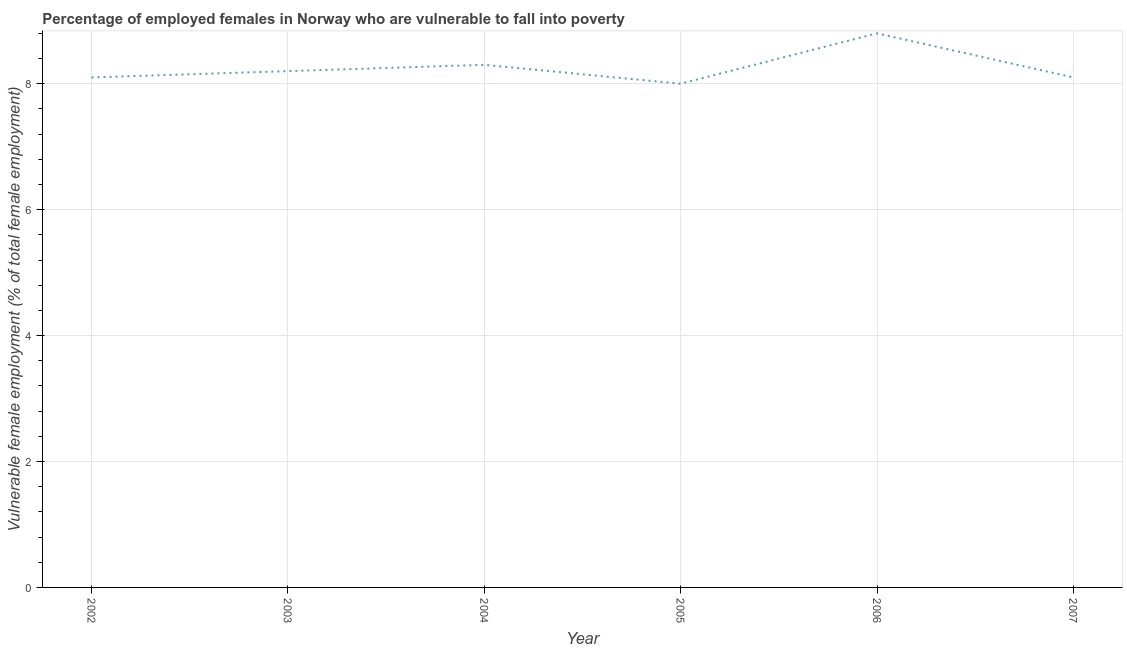What is the percentage of employed females who are vulnerable to fall into poverty in 2004?
Your answer should be very brief. 8.3. Across all years, what is the maximum percentage of employed females who are vulnerable to fall into poverty?
Your answer should be very brief. 8.8. Across all years, what is the minimum percentage of employed females who are vulnerable to fall into poverty?
Provide a short and direct response. 8. In which year was the percentage of employed females who are vulnerable to fall into poverty minimum?
Make the answer very short. 2005. What is the sum of the percentage of employed females who are vulnerable to fall into poverty?
Offer a very short reply. 49.5. What is the difference between the percentage of employed females who are vulnerable to fall into poverty in 2006 and 2007?
Offer a terse response. 0.7. What is the average percentage of employed females who are vulnerable to fall into poverty per year?
Provide a short and direct response. 8.25. What is the median percentage of employed females who are vulnerable to fall into poverty?
Make the answer very short. 8.15. What is the ratio of the percentage of employed females who are vulnerable to fall into poverty in 2002 to that in 2003?
Provide a succinct answer. 0.99. Is the percentage of employed females who are vulnerable to fall into poverty in 2002 less than that in 2005?
Give a very brief answer. No. What is the difference between the highest and the second highest percentage of employed females who are vulnerable to fall into poverty?
Your answer should be compact. 0.5. Is the sum of the percentage of employed females who are vulnerable to fall into poverty in 2004 and 2007 greater than the maximum percentage of employed females who are vulnerable to fall into poverty across all years?
Your answer should be very brief. Yes. What is the difference between the highest and the lowest percentage of employed females who are vulnerable to fall into poverty?
Keep it short and to the point. 0.8. In how many years, is the percentage of employed females who are vulnerable to fall into poverty greater than the average percentage of employed females who are vulnerable to fall into poverty taken over all years?
Your answer should be compact. 2. Does the percentage of employed females who are vulnerable to fall into poverty monotonically increase over the years?
Keep it short and to the point. No. How many lines are there?
Your answer should be compact. 1. How many years are there in the graph?
Give a very brief answer. 6. Does the graph contain any zero values?
Offer a very short reply. No. Does the graph contain grids?
Your answer should be very brief. Yes. What is the title of the graph?
Ensure brevity in your answer.  Percentage of employed females in Norway who are vulnerable to fall into poverty. What is the label or title of the X-axis?
Provide a short and direct response. Year. What is the label or title of the Y-axis?
Give a very brief answer. Vulnerable female employment (% of total female employment). What is the Vulnerable female employment (% of total female employment) of 2002?
Provide a succinct answer. 8.1. What is the Vulnerable female employment (% of total female employment) in 2003?
Your answer should be compact. 8.2. What is the Vulnerable female employment (% of total female employment) in 2004?
Ensure brevity in your answer.  8.3. What is the Vulnerable female employment (% of total female employment) in 2005?
Your response must be concise. 8. What is the Vulnerable female employment (% of total female employment) in 2006?
Provide a succinct answer. 8.8. What is the Vulnerable female employment (% of total female employment) of 2007?
Your response must be concise. 8.1. What is the difference between the Vulnerable female employment (% of total female employment) in 2002 and 2004?
Offer a terse response. -0.2. What is the difference between the Vulnerable female employment (% of total female employment) in 2002 and 2005?
Ensure brevity in your answer.  0.1. What is the difference between the Vulnerable female employment (% of total female employment) in 2002 and 2006?
Ensure brevity in your answer.  -0.7. What is the difference between the Vulnerable female employment (% of total female employment) in 2003 and 2007?
Provide a short and direct response. 0.1. What is the difference between the Vulnerable female employment (% of total female employment) in 2004 and 2005?
Your answer should be compact. 0.3. What is the difference between the Vulnerable female employment (% of total female employment) in 2005 and 2006?
Your response must be concise. -0.8. What is the difference between the Vulnerable female employment (% of total female employment) in 2005 and 2007?
Give a very brief answer. -0.1. What is the difference between the Vulnerable female employment (% of total female employment) in 2006 and 2007?
Offer a terse response. 0.7. What is the ratio of the Vulnerable female employment (% of total female employment) in 2002 to that in 2004?
Ensure brevity in your answer.  0.98. What is the ratio of the Vulnerable female employment (% of total female employment) in 2002 to that in 2005?
Your answer should be compact. 1.01. What is the ratio of the Vulnerable female employment (% of total female employment) in 2002 to that in 2006?
Offer a very short reply. 0.92. What is the ratio of the Vulnerable female employment (% of total female employment) in 2003 to that in 2006?
Keep it short and to the point. 0.93. What is the ratio of the Vulnerable female employment (% of total female employment) in 2003 to that in 2007?
Ensure brevity in your answer.  1.01. What is the ratio of the Vulnerable female employment (% of total female employment) in 2004 to that in 2005?
Your response must be concise. 1.04. What is the ratio of the Vulnerable female employment (% of total female employment) in 2004 to that in 2006?
Keep it short and to the point. 0.94. What is the ratio of the Vulnerable female employment (% of total female employment) in 2005 to that in 2006?
Give a very brief answer. 0.91. What is the ratio of the Vulnerable female employment (% of total female employment) in 2005 to that in 2007?
Offer a terse response. 0.99. What is the ratio of the Vulnerable female employment (% of total female employment) in 2006 to that in 2007?
Provide a short and direct response. 1.09. 